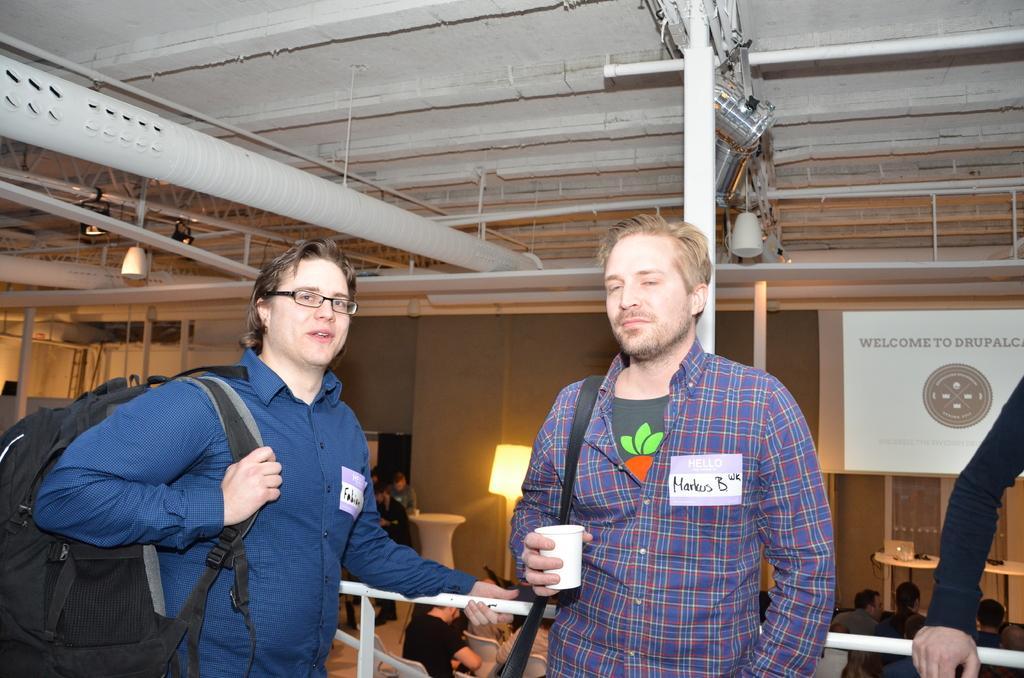Can you describe this image briefly? The picture is taken in a restaurant. In the foreground of the picture there are two men standing wearing backpacks. On the right there is a person's hand. In the center towards right there is a hoarding. On the top it is ceiling. In the middle of the picture there are pipes, poles and frames. In the background there are people sitting in chairs. In the center of the background there is a lamp. 